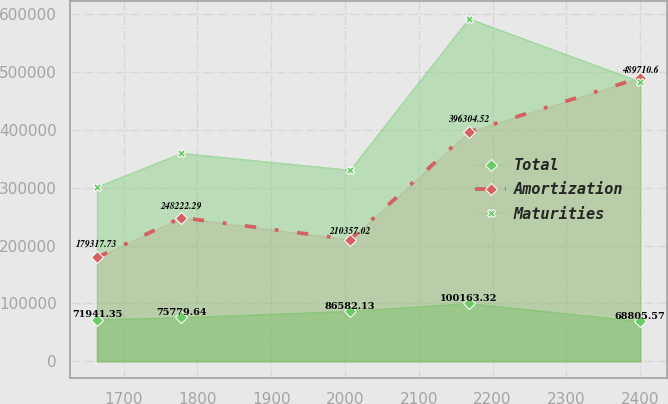<chart> <loc_0><loc_0><loc_500><loc_500><line_chart><ecel><fcel>Total<fcel>Amortization<fcel>Maturities<nl><fcel>1664<fcel>71941.4<fcel>179318<fcel>301466<nl><fcel>1778.31<fcel>75779.6<fcel>248222<fcel>359603<nl><fcel>2006.91<fcel>86582.1<fcel>210357<fcel>330534<nl><fcel>2167.74<fcel>100163<fcel>396305<fcel>592151<nl><fcel>2399.96<fcel>68805.6<fcel>489711<fcel>482962<nl></chart> 